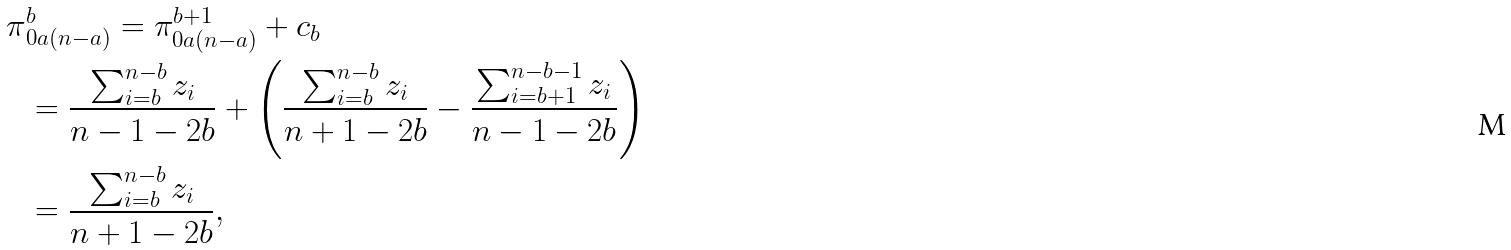<formula> <loc_0><loc_0><loc_500><loc_500>\pi & ^ { b } _ { 0 a ( n - a ) } = \pi ^ { b + 1 } _ { 0 a ( n - a ) } + c _ { b } \\ & = \frac { \sum _ { i = b } ^ { n - b } z _ { i } } { n - 1 - 2 b } + \left ( \frac { \sum _ { i = b } ^ { n - b } z _ { i } } { n + 1 - 2 b } - \frac { \sum _ { i = b + 1 } ^ { n - b - 1 } z _ { i } } { n - 1 - 2 b } \right ) \\ & = \frac { \sum _ { i = b } ^ { n - b } z _ { i } } { n + 1 - 2 b } ,</formula> 